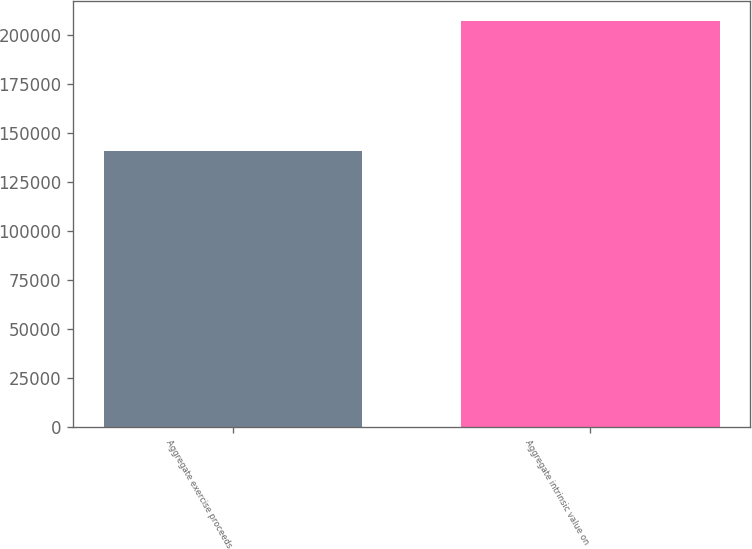Convert chart. <chart><loc_0><loc_0><loc_500><loc_500><bar_chart><fcel>Aggregate exercise proceeds<fcel>Aggregate intrinsic value on<nl><fcel>140525<fcel>206890<nl></chart> 